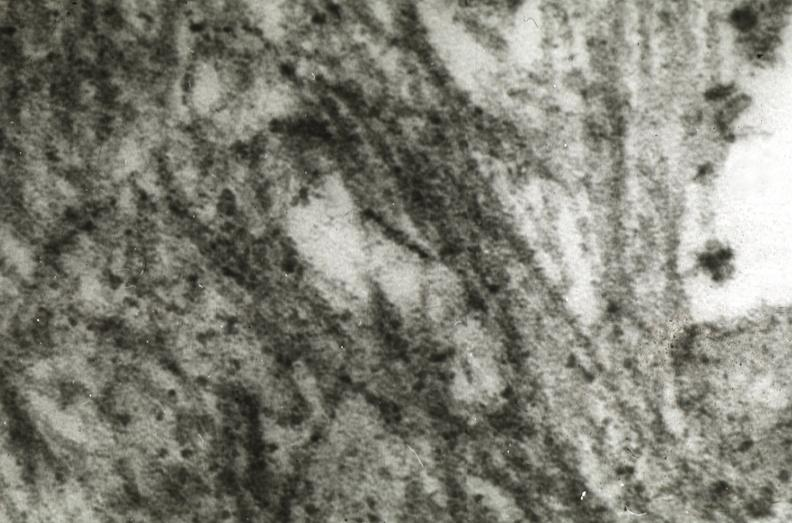what does this image show?
Answer the question using a single word or phrase. Amyloidosis 